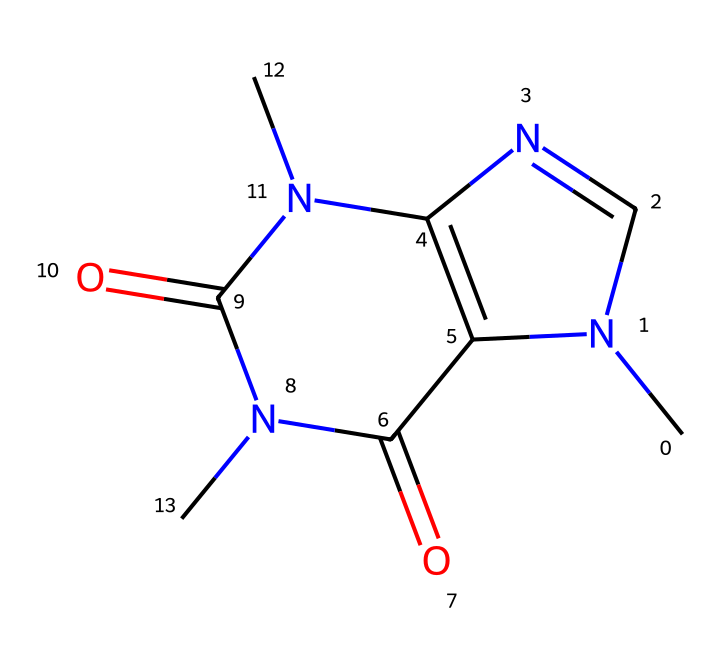What is the chemical name of this compound? The SMILES representation corresponds to caffeine, a well-known stimulant found in coffee.
Answer: caffeine How many nitrogen atoms are present in this structure? By examining the visual structure and counting, there are four nitrogen atoms in the caffeine molecule.
Answer: four What type of chemical bond primarily connects the carbon and nitrogen atoms in this structure? The carbon and nitrogen atoms are held together by covalent bonds, which involve the sharing of electrons between atoms.
Answer: covalent What functional groups can be identified in caffeine? The compound contains amide functional groups due to the presence of nitrogen atoms bonded to carbonyl groups (C=O).
Answer: amide How many rings are present in the caffeine structure? The structure has two rings forming a bicyclic arrangement, specifically a pyrimidine and an imidazole ring.
Answer: two What aspect of caffeine contributes to its stimulant properties? The presence of nitrogen atoms in a specific arrangement creates a structure that interacts with adenine receptors in the brain, enhancing alertness.
Answer: nitrogen 